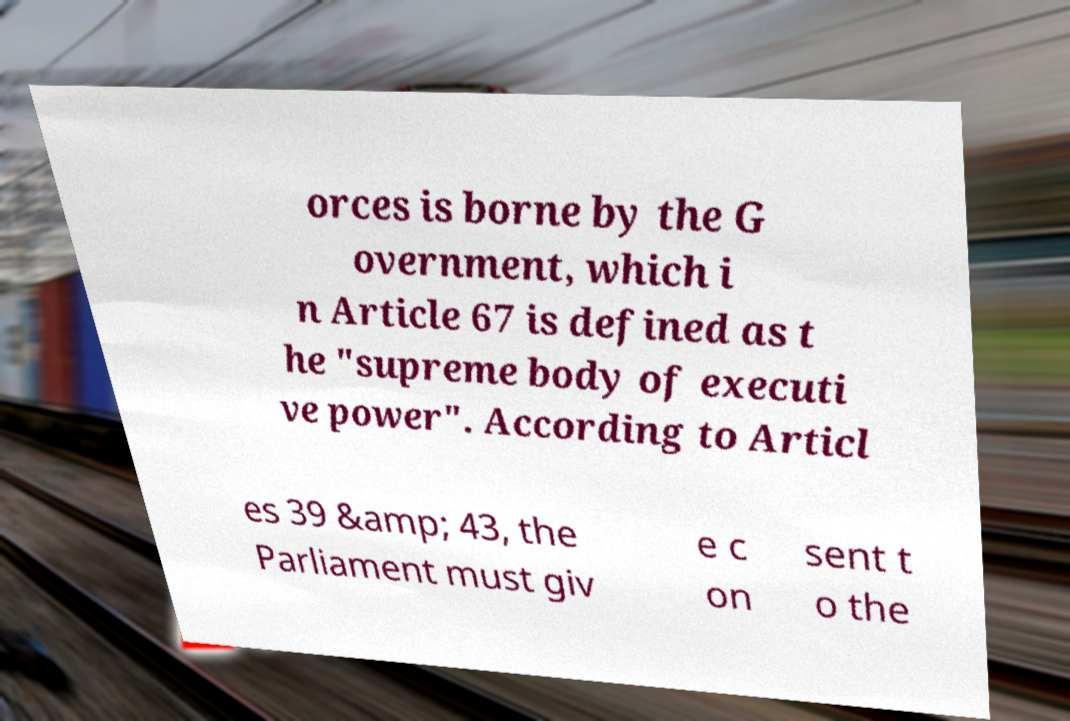What messages or text are displayed in this image? I need them in a readable, typed format. orces is borne by the G overnment, which i n Article 67 is defined as t he "supreme body of executi ve power". According to Articl es 39 &amp; 43, the Parliament must giv e c on sent t o the 